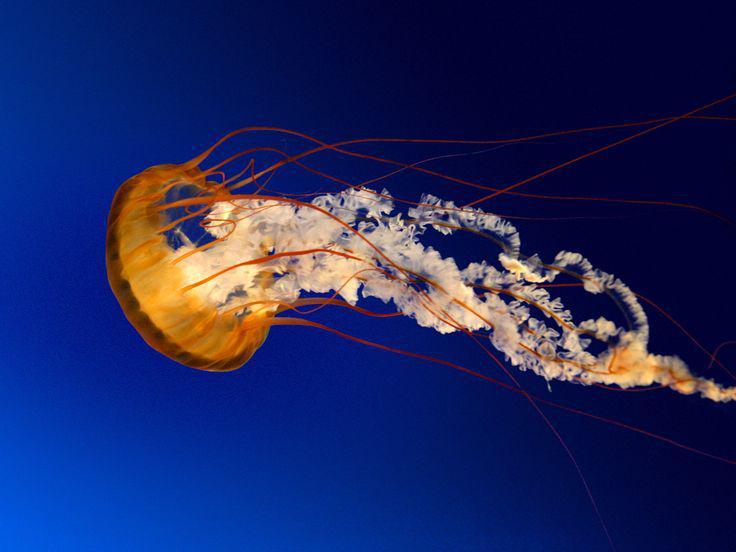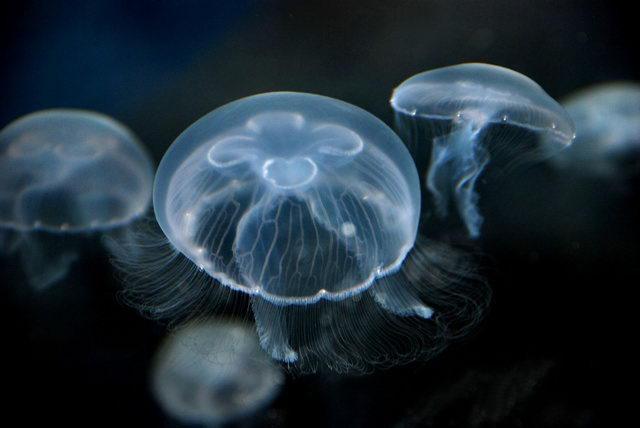The first image is the image on the left, the second image is the image on the right. Analyze the images presented: Is the assertion "The jellyfish in the left and right images are generally the same color, and no single image contains more than two jellyfish." valid? Answer yes or no. No. The first image is the image on the left, the second image is the image on the right. Given the left and right images, does the statement "The jellyfish in the right image are translucent." hold true? Answer yes or no. Yes. 